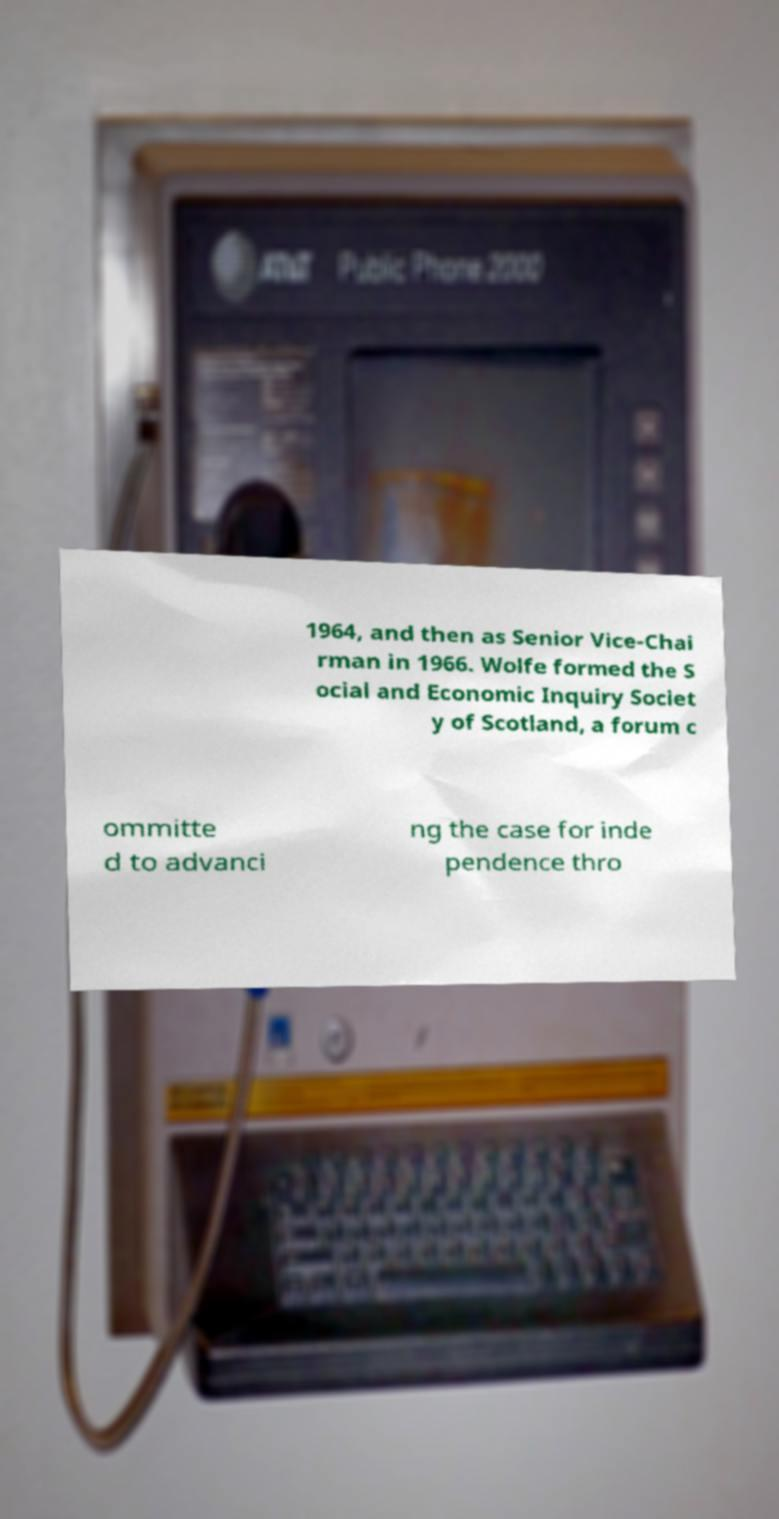There's text embedded in this image that I need extracted. Can you transcribe it verbatim? 1964, and then as Senior Vice-Chai rman in 1966. Wolfe formed the S ocial and Economic Inquiry Societ y of Scotland, a forum c ommitte d to advanci ng the case for inde pendence thro 